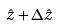Convert formula to latex. <formula><loc_0><loc_0><loc_500><loc_500>\hat { z } + \Delta \hat { z }</formula> 